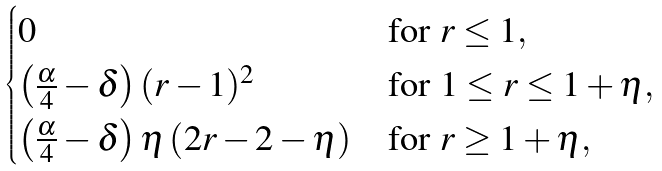<formula> <loc_0><loc_0><loc_500><loc_500>\begin{cases} 0 & \text {for } r \leq 1 , \\ \left ( \frac { \alpha } { 4 } - \delta \right ) ( r - 1 ) ^ { 2 } & \text {for } 1 \leq r \leq 1 + \eta , \\ \left ( \frac { \alpha } { 4 } - \delta \right ) \eta \left ( 2 r - 2 - \eta \right ) & \text {for } r \geq 1 + \eta , \end{cases}</formula> 